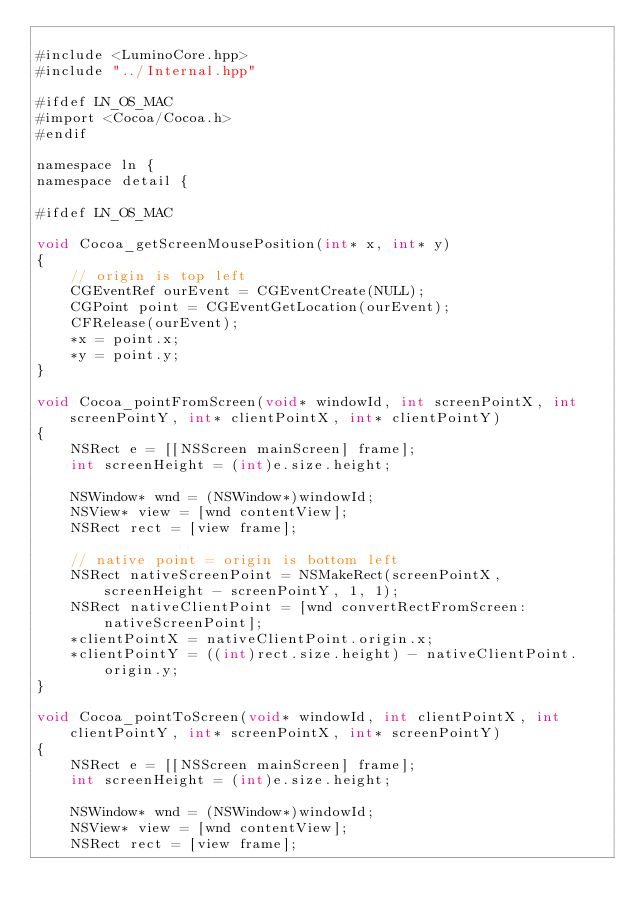<code> <loc_0><loc_0><loc_500><loc_500><_ObjectiveC_>
#include <LuminoCore.hpp>
#include "../Internal.hpp"

#ifdef LN_OS_MAC
#import <Cocoa/Cocoa.h>
#endif

namespace ln {
namespace detail {

#ifdef LN_OS_MAC

void Cocoa_getScreenMousePosition(int* x, int* y)
{
	// origin is top left
	CGEventRef ourEvent = CGEventCreate(NULL);
	CGPoint point = CGEventGetLocation(ourEvent);
	CFRelease(ourEvent);
	*x = point.x;
	*y = point.y;
}

void Cocoa_pointFromScreen(void* windowId, int screenPointX, int screenPointY, int* clientPointX, int* clientPointY)
{
	NSRect e = [[NSScreen mainScreen] frame];
	int screenHeight = (int)e.size.height;
	
	NSWindow* wnd = (NSWindow*)windowId;
	NSView* view = [wnd contentView];
	NSRect rect = [view frame];
	
	// native point = origin is bottom left
	NSRect nativeScreenPoint = NSMakeRect(screenPointX, screenHeight - screenPointY, 1, 1);
	NSRect nativeClientPoint = [wnd convertRectFromScreen:nativeScreenPoint];
	*clientPointX = nativeClientPoint.origin.x;
	*clientPointY = ((int)rect.size.height) - nativeClientPoint.origin.y;
}

void Cocoa_pointToScreen(void* windowId, int clientPointX, int clientPointY, int* screenPointX, int* screenPointY)
{
	NSRect e = [[NSScreen mainScreen] frame];
	int screenHeight = (int)e.size.height;
		
	NSWindow* wnd = (NSWindow*)windowId;
	NSView* view = [wnd contentView];
	NSRect rect = [view frame];
	</code> 